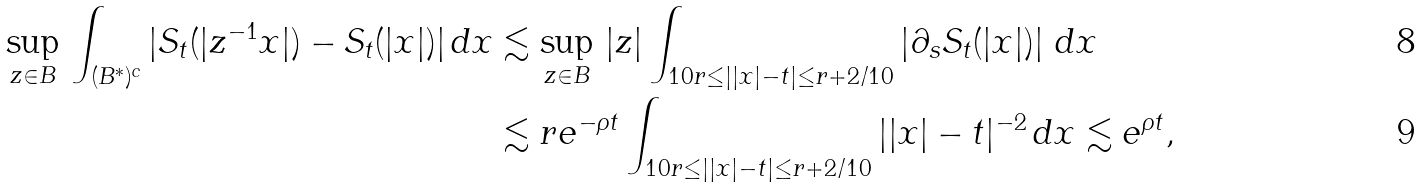Convert formula to latex. <formula><loc_0><loc_0><loc_500><loc_500>\sup _ { z \in B } \, \int _ { ( B ^ { * } ) ^ { c } } | S _ { t } ( | z ^ { - 1 } x | ) - S _ { t } ( | x | ) | \, d x & \lesssim \sup _ { z \in B } \, | z | \int _ { 1 0 r \leq | | x | - t | \leq r + 2 / 1 0 } \left | \partial _ { s } S _ { t } ( | x | ) \right | \, d x \\ & \lesssim r e ^ { - \rho t } \int _ { 1 0 r \leq | | x | - t | \leq r + 2 / 1 0 } | | x | - t | ^ { - 2 } \, d x \lesssim e ^ { \rho t } ,</formula> 